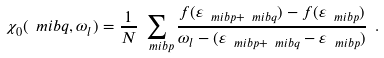Convert formula to latex. <formula><loc_0><loc_0><loc_500><loc_500>\chi _ { 0 } ( \ m i b { q } , \omega _ { l } ) = \frac { 1 } { N } \sum _ { \ m i b { p } } \frac { f ( \varepsilon _ { \ m i b { p } + \ m i b { q } } ) - f ( \varepsilon _ { \ m i b { p } } ) } { \omega _ { l } - ( \varepsilon _ { \ m i b { p } + \ m i b { q } } - \varepsilon _ { \ m i b { p } } ) } \ .</formula> 